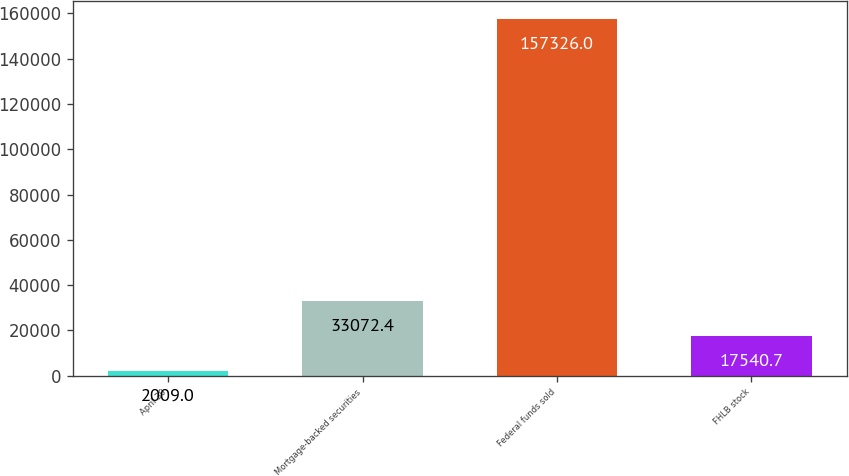Convert chart. <chart><loc_0><loc_0><loc_500><loc_500><bar_chart><fcel>April 30<fcel>Mortgage-backed securities<fcel>Federal funds sold<fcel>FHLB stock<nl><fcel>2009<fcel>33072.4<fcel>157326<fcel>17540.7<nl></chart> 